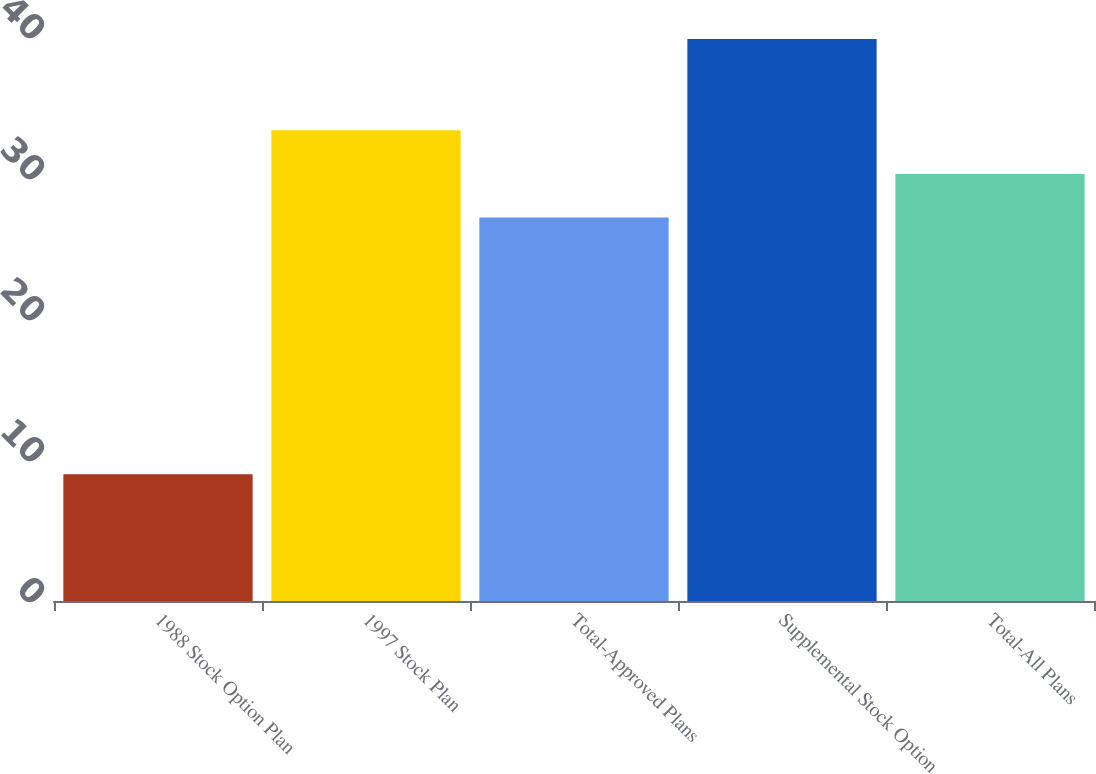<chart> <loc_0><loc_0><loc_500><loc_500><bar_chart><fcel>1988 Stock Option Plan<fcel>1997 Stock Plan<fcel>Total-Approved Plans<fcel>Supplemental Stock Option<fcel>Total-All Plans<nl><fcel>8.99<fcel>33.38<fcel>27.2<fcel>39.85<fcel>30.29<nl></chart> 